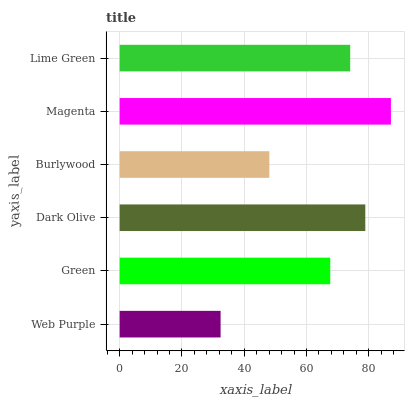Is Web Purple the minimum?
Answer yes or no. Yes. Is Magenta the maximum?
Answer yes or no. Yes. Is Green the minimum?
Answer yes or no. No. Is Green the maximum?
Answer yes or no. No. Is Green greater than Web Purple?
Answer yes or no. Yes. Is Web Purple less than Green?
Answer yes or no. Yes. Is Web Purple greater than Green?
Answer yes or no. No. Is Green less than Web Purple?
Answer yes or no. No. Is Lime Green the high median?
Answer yes or no. Yes. Is Green the low median?
Answer yes or no. Yes. Is Web Purple the high median?
Answer yes or no. No. Is Burlywood the low median?
Answer yes or no. No. 